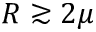<formula> <loc_0><loc_0><loc_500><loc_500>R \gtrsim 2 \mu</formula> 